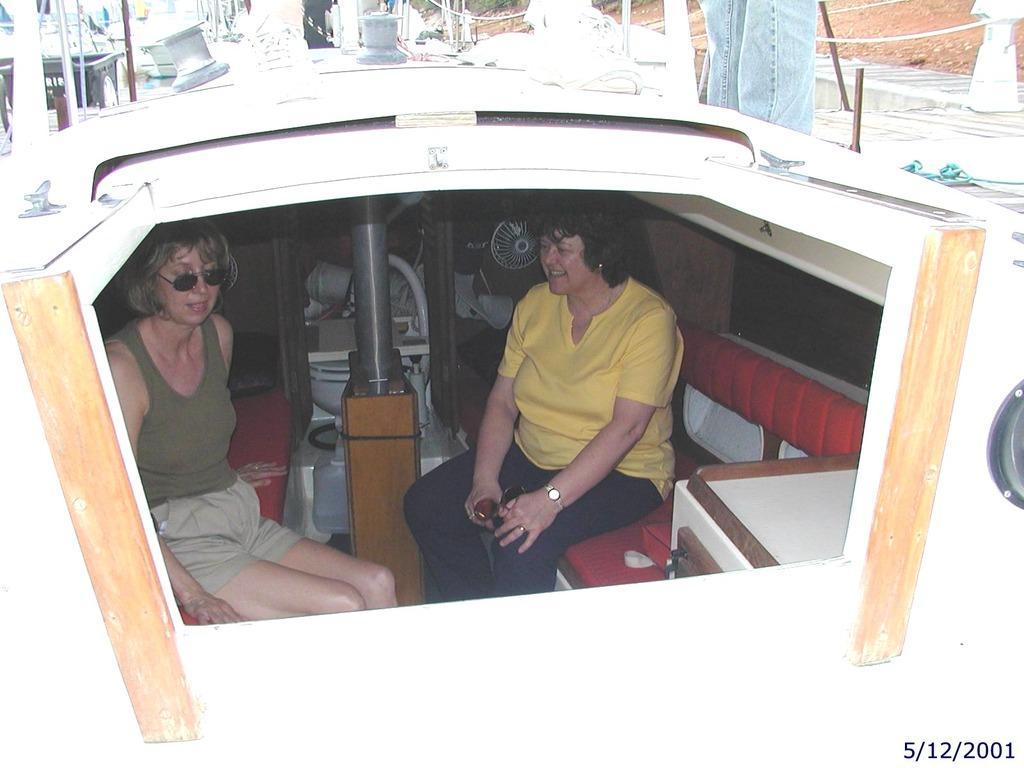In one or two sentences, can you explain what this image depicts? In this image I can see a boat which is white and cream in color and in the boat I can see two women sitting on benches which are red in color and a person wearing jeans is standing on the boat. In the background I can see few other objects. 